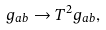Convert formula to latex. <formula><loc_0><loc_0><loc_500><loc_500>g _ { a b } \to T ^ { 2 } g _ { a b } ,</formula> 